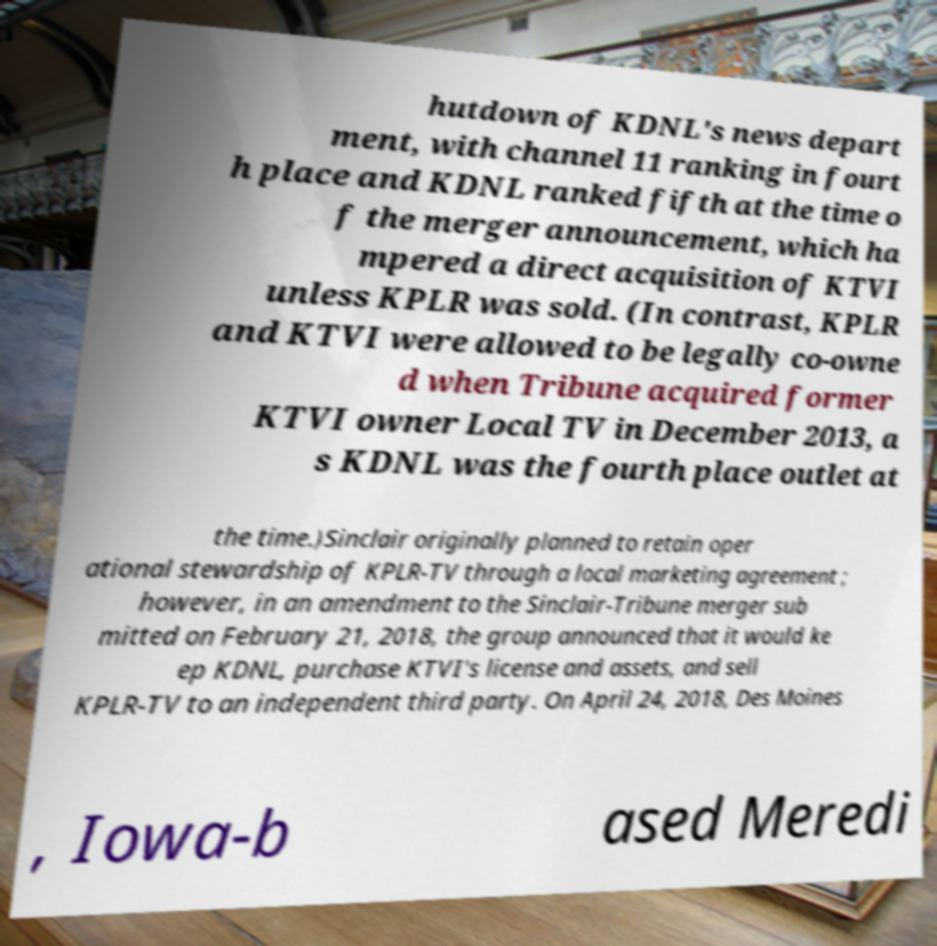Please identify and transcribe the text found in this image. hutdown of KDNL's news depart ment, with channel 11 ranking in fourt h place and KDNL ranked fifth at the time o f the merger announcement, which ha mpered a direct acquisition of KTVI unless KPLR was sold. (In contrast, KPLR and KTVI were allowed to be legally co-owne d when Tribune acquired former KTVI owner Local TV in December 2013, a s KDNL was the fourth place outlet at the time.)Sinclair originally planned to retain oper ational stewardship of KPLR-TV through a local marketing agreement ; however, in an amendment to the Sinclair-Tribune merger sub mitted on February 21, 2018, the group announced that it would ke ep KDNL, purchase KTVI's license and assets, and sell KPLR-TV to an independent third party. On April 24, 2018, Des Moines , Iowa-b ased Meredi 